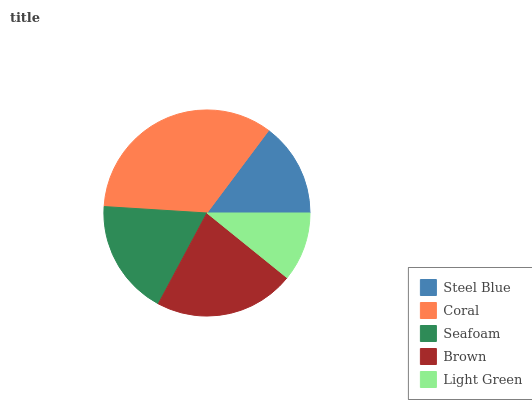Is Light Green the minimum?
Answer yes or no. Yes. Is Coral the maximum?
Answer yes or no. Yes. Is Seafoam the minimum?
Answer yes or no. No. Is Seafoam the maximum?
Answer yes or no. No. Is Coral greater than Seafoam?
Answer yes or no. Yes. Is Seafoam less than Coral?
Answer yes or no. Yes. Is Seafoam greater than Coral?
Answer yes or no. No. Is Coral less than Seafoam?
Answer yes or no. No. Is Seafoam the high median?
Answer yes or no. Yes. Is Seafoam the low median?
Answer yes or no. Yes. Is Steel Blue the high median?
Answer yes or no. No. Is Light Green the low median?
Answer yes or no. No. 